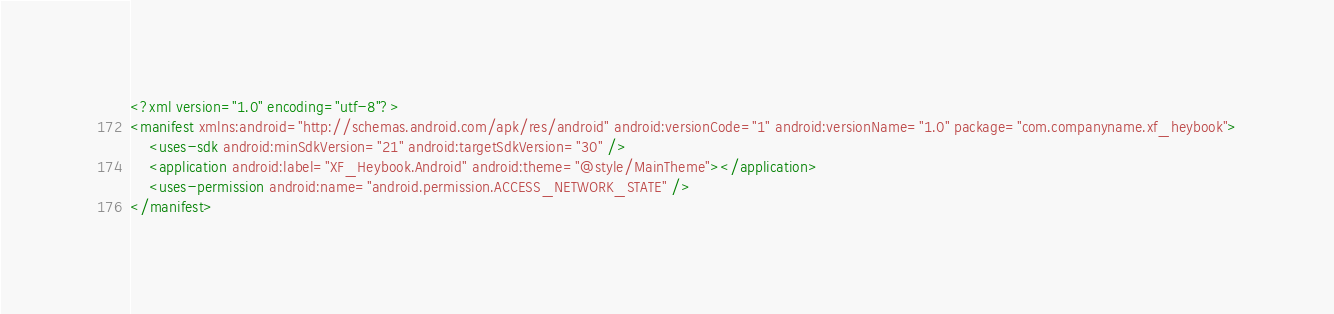<code> <loc_0><loc_0><loc_500><loc_500><_XML_><?xml version="1.0" encoding="utf-8"?>
<manifest xmlns:android="http://schemas.android.com/apk/res/android" android:versionCode="1" android:versionName="1.0" package="com.companyname.xf_heybook">
    <uses-sdk android:minSdkVersion="21" android:targetSdkVersion="30" />
    <application android:label="XF_Heybook.Android" android:theme="@style/MainTheme"></application>
    <uses-permission android:name="android.permission.ACCESS_NETWORK_STATE" />
</manifest>
</code> 